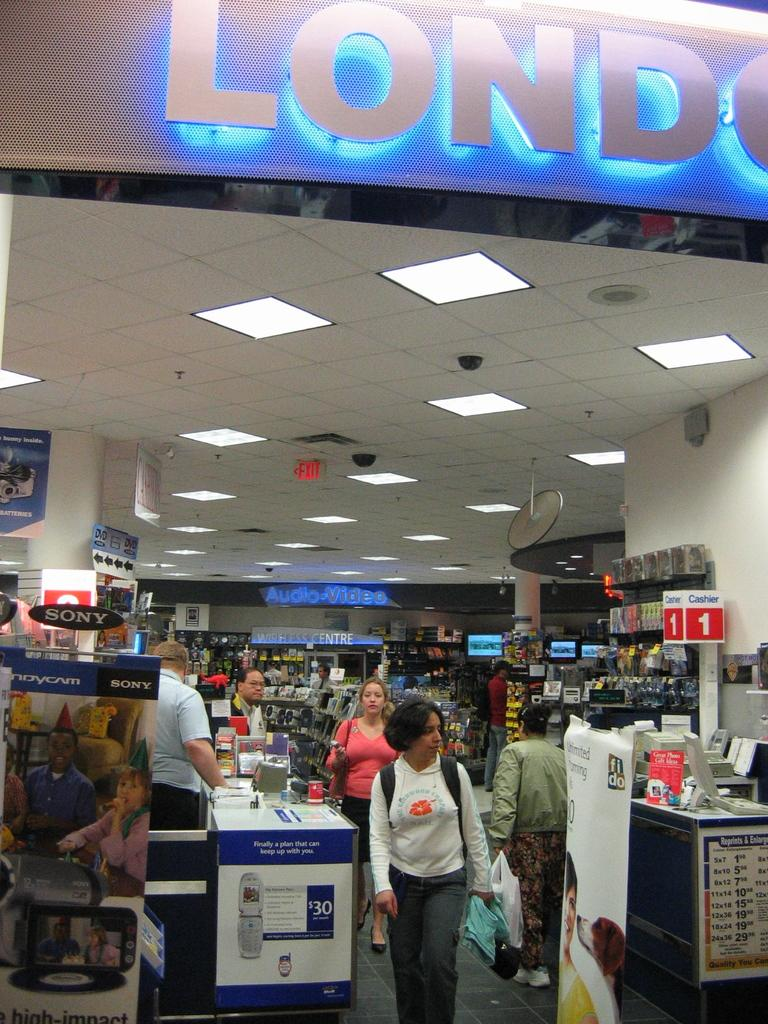<image>
Render a clear and concise summary of the photo. Reprints & Enlargement photo pricing at register 1. 